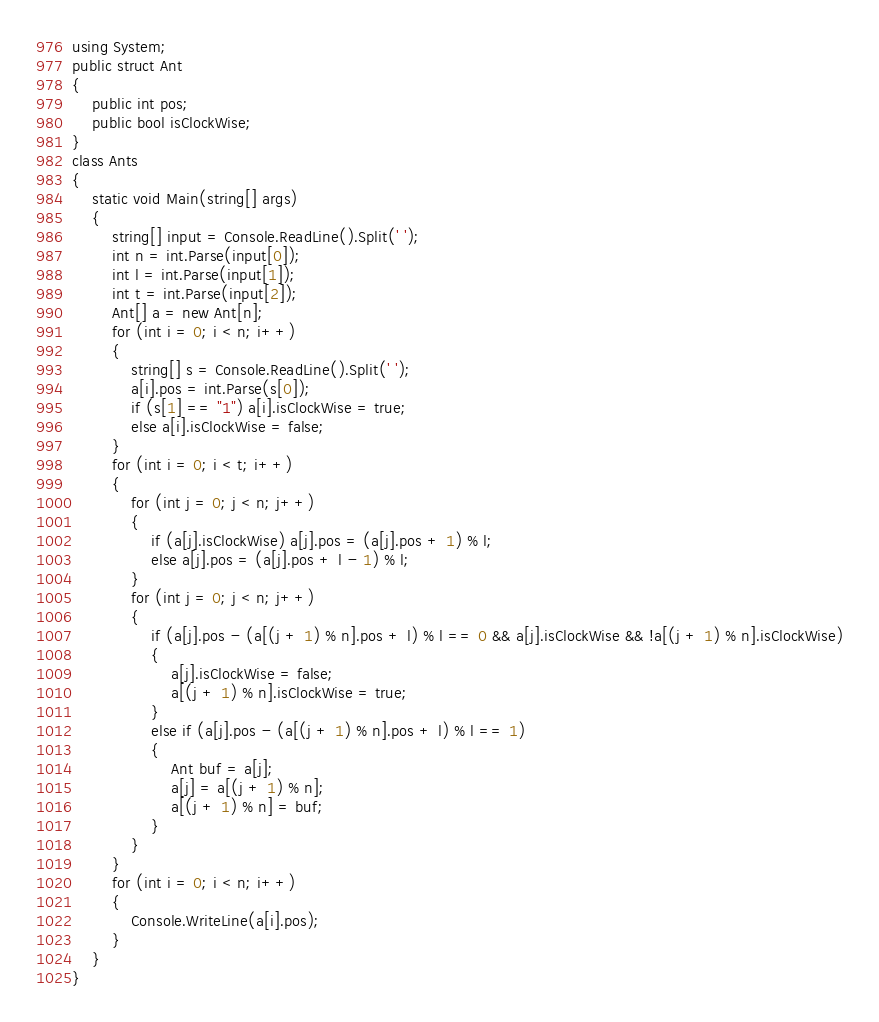<code> <loc_0><loc_0><loc_500><loc_500><_C#_>using System;
public struct Ant
{
    public int pos;
    public bool isClockWise;
}
class Ants
{
    static void Main(string[] args)
    {
        string[] input = Console.ReadLine().Split(' ');
        int n = int.Parse(input[0]);
        int l = int.Parse(input[1]);
        int t = int.Parse(input[2]);
        Ant[] a = new Ant[n];
        for (int i = 0; i < n; i++)
        {
            string[] s = Console.ReadLine().Split(' ');
            a[i].pos = int.Parse(s[0]);
            if (s[1] == "1") a[i].isClockWise = true;
            else a[i].isClockWise = false;
        }
        for (int i = 0; i < t; i++)
        {
            for (int j = 0; j < n; j++)
            {
                if (a[j].isClockWise) a[j].pos = (a[j].pos + 1) % l;
                else a[j].pos = (a[j].pos + l - 1) % l;
            }
            for (int j = 0; j < n; j++)
            {
                if (a[j].pos - (a[(j + 1) % n].pos + l) % l == 0 && a[j].isClockWise && !a[(j + 1) % n].isClockWise)
                {
                    a[j].isClockWise = false;
                    a[(j + 1) % n].isClockWise = true;
                }
                else if (a[j].pos - (a[(j + 1) % n].pos + l) % l == 1)
                {
                    Ant buf = a[j];
                    a[j] = a[(j + 1) % n];
                    a[(j + 1) % n] = buf;
                }
            }
        }
        for (int i = 0; i < n; i++)
        {
            Console.WriteLine(a[i].pos);
        }
    }
}</code> 